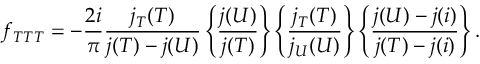Convert formula to latex. <formula><loc_0><loc_0><loc_500><loc_500>f _ { T T T } = - { \frac { 2 i } { \pi } } \frac { j _ { T } ( T ) } { j ( T ) - j ( U ) } \left \{ \frac { j ( U ) } { j ( T ) } \right \} \left \{ \frac { j _ { T } ( T ) } { j _ { U } ( U ) } \right \} \left \{ \frac { j ( U ) - j ( i ) } { j ( T ) - j ( i ) } \right \} .</formula> 